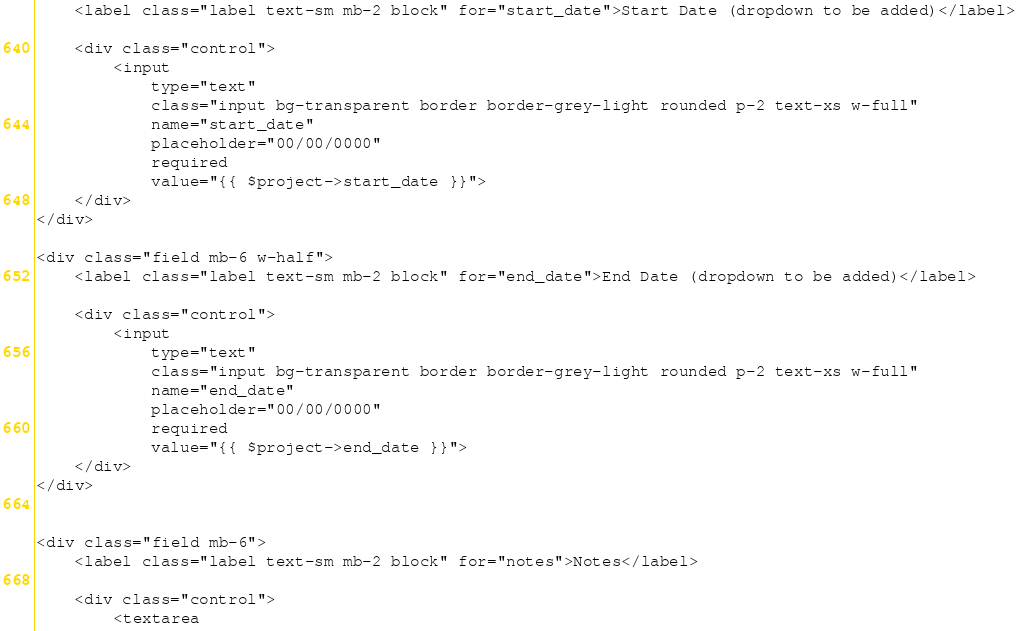Convert code to text. <code><loc_0><loc_0><loc_500><loc_500><_PHP_>    <label class="label text-sm mb-2 block" for="start_date">Start Date (dropdown to be added)</label>

    <div class="control">
        <input 
            type="text" 
            class="input bg-transparent border border-grey-light rounded p-2 text-xs w-full" 
            name="start_date" 
            placeholder="00/00/0000"
            required
            value="{{ $project->start_date }}">
    </div>
</div>

<div class="field mb-6 w-half">
    <label class="label text-sm mb-2 block" for="end_date">End Date (dropdown to be added)</label>

    <div class="control">
        <input 
            type="text" 
            class="input bg-transparent border border-grey-light rounded p-2 text-xs w-full" 
            name="end_date" 
            placeholder="00/00/0000"
            required
            value="{{ $project->end_date }}">
    </div>
</div>


<div class="field mb-6">
    <label class="label text-sm mb-2 block" for="notes">Notes</label>

    <div class="control">
        <textarea </code> 